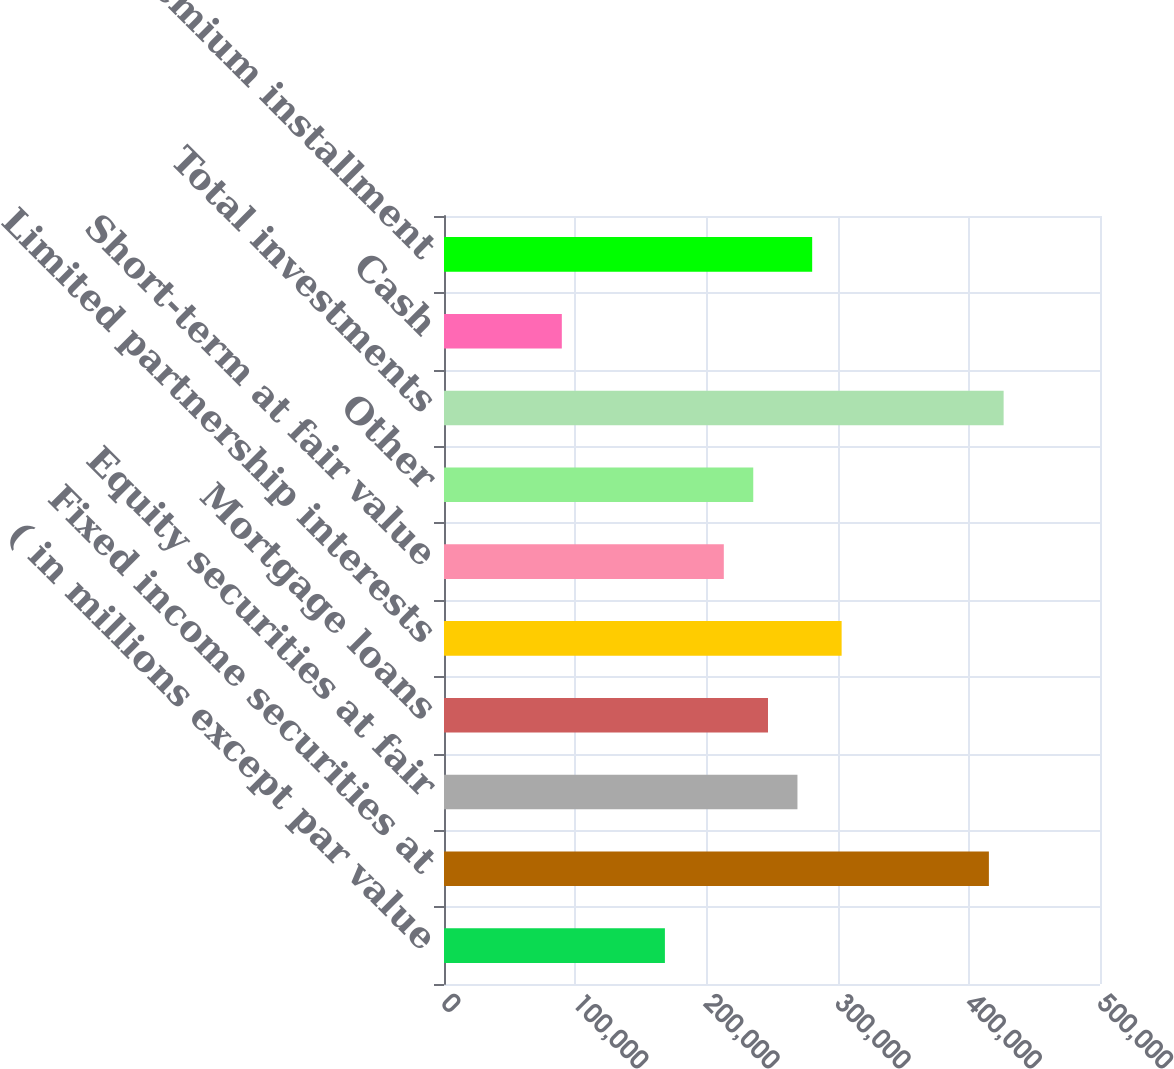Convert chart. <chart><loc_0><loc_0><loc_500><loc_500><bar_chart><fcel>( in millions except par value<fcel>Fixed income securities at<fcel>Equity securities at fair<fcel>Mortgage loans<fcel>Limited partnership interests<fcel>Short-term at fair value<fcel>Other<fcel>Total investments<fcel>Cash<fcel>Premium installment<nl><fcel>168372<fcel>415316<fcel>269395<fcel>246945<fcel>303069<fcel>213271<fcel>235721<fcel>426541<fcel>89799.6<fcel>280620<nl></chart> 